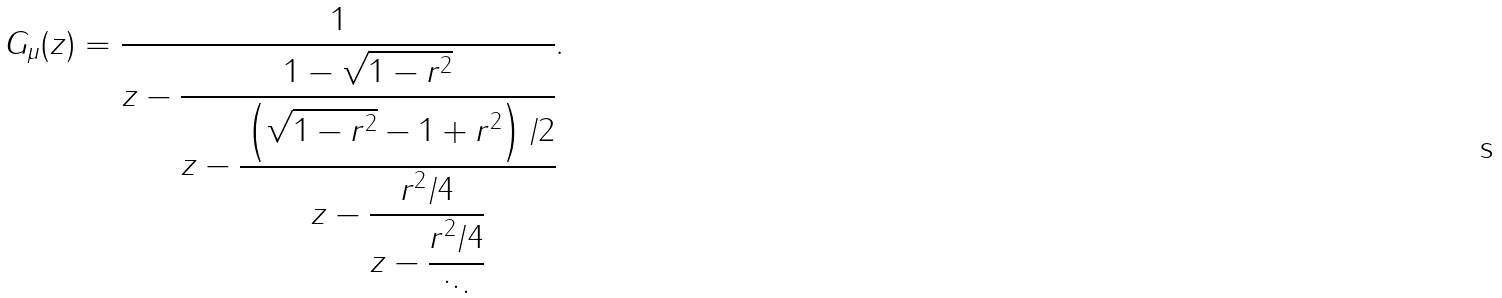Convert formula to latex. <formula><loc_0><loc_0><loc_500><loc_500>G _ { \mu } ( z ) = \cfrac { 1 } { z - \cfrac { 1 - \sqrt { 1 - r ^ { 2 } } } { z - \cfrac { \left ( \sqrt { 1 - r ^ { 2 } } - 1 + r ^ { 2 } \right ) / 2 } { z - \cfrac { r ^ { 2 } / 4 } { z - \cfrac { r ^ { 2 } / 4 } { \ddots } } } } } .</formula> 